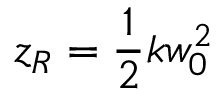<formula> <loc_0><loc_0><loc_500><loc_500>z _ { R } = \frac { 1 } { 2 } k w _ { 0 } ^ { 2 }</formula> 